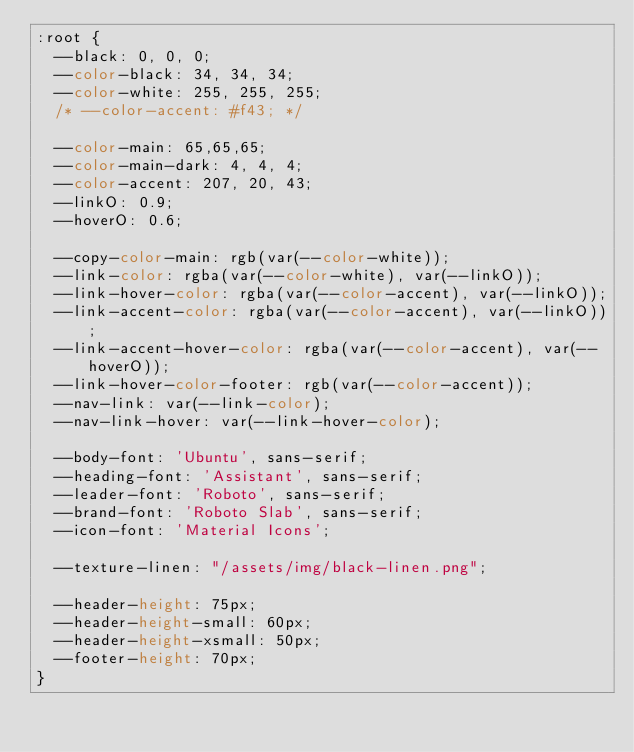<code> <loc_0><loc_0><loc_500><loc_500><_CSS_>:root {
  --black: 0, 0, 0;
  --color-black: 34, 34, 34;
  --color-white: 255, 255, 255;
  /* --color-accent: #f43; */

  --color-main: 65,65,65;
  --color-main-dark: 4, 4, 4;
  --color-accent: 207, 20, 43;
  --linkO: 0.9;
  --hoverO: 0.6;

  --copy-color-main: rgb(var(--color-white));
  --link-color: rgba(var(--color-white), var(--linkO));
  --link-hover-color: rgba(var(--color-accent), var(--linkO));
  --link-accent-color: rgba(var(--color-accent), var(--linkO));
  --link-accent-hover-color: rgba(var(--color-accent), var(--hoverO));
  --link-hover-color-footer: rgb(var(--color-accent));
  --nav-link: var(--link-color);
  --nav-link-hover: var(--link-hover-color);

  --body-font: 'Ubuntu', sans-serif;
  --heading-font: 'Assistant', sans-serif;
  --leader-font: 'Roboto', sans-serif;
  --brand-font: 'Roboto Slab', sans-serif;
  --icon-font: 'Material Icons';

  --texture-linen: "/assets/img/black-linen.png";

  --header-height: 75px;
  --header-height-small: 60px;
  --header-height-xsmall: 50px;
  --footer-height: 70px;
}
</code> 